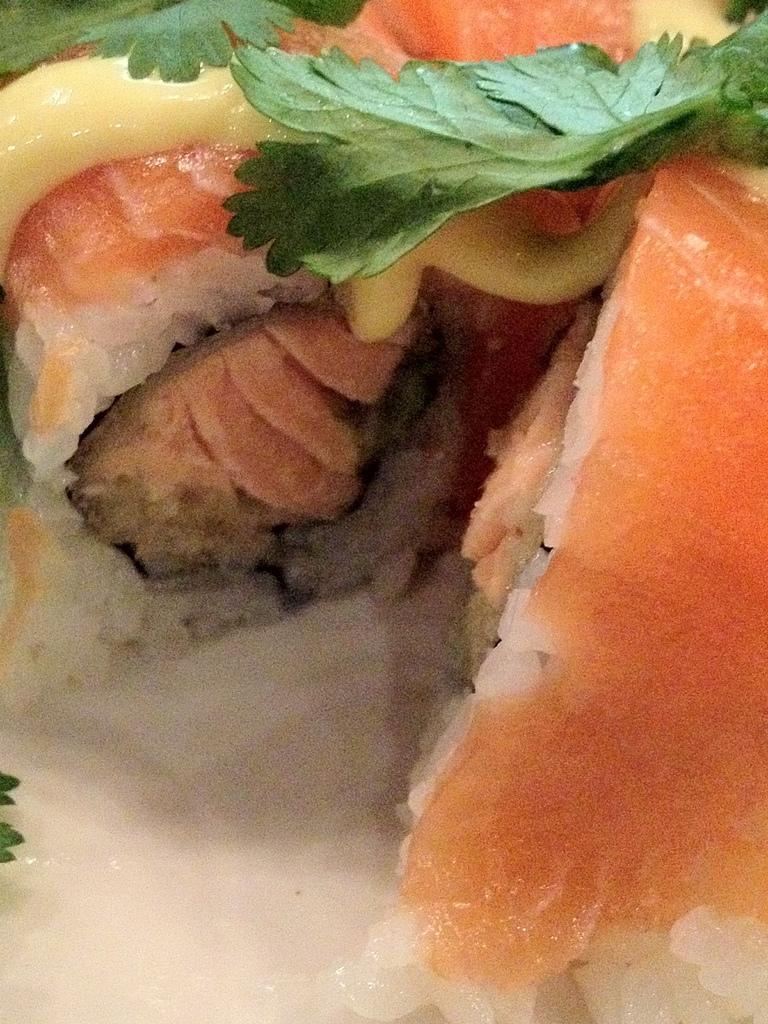In one or two sentences, can you explain what this image depicts? In the center of the image we can see some food item, in which we can see the meat and leaves. 